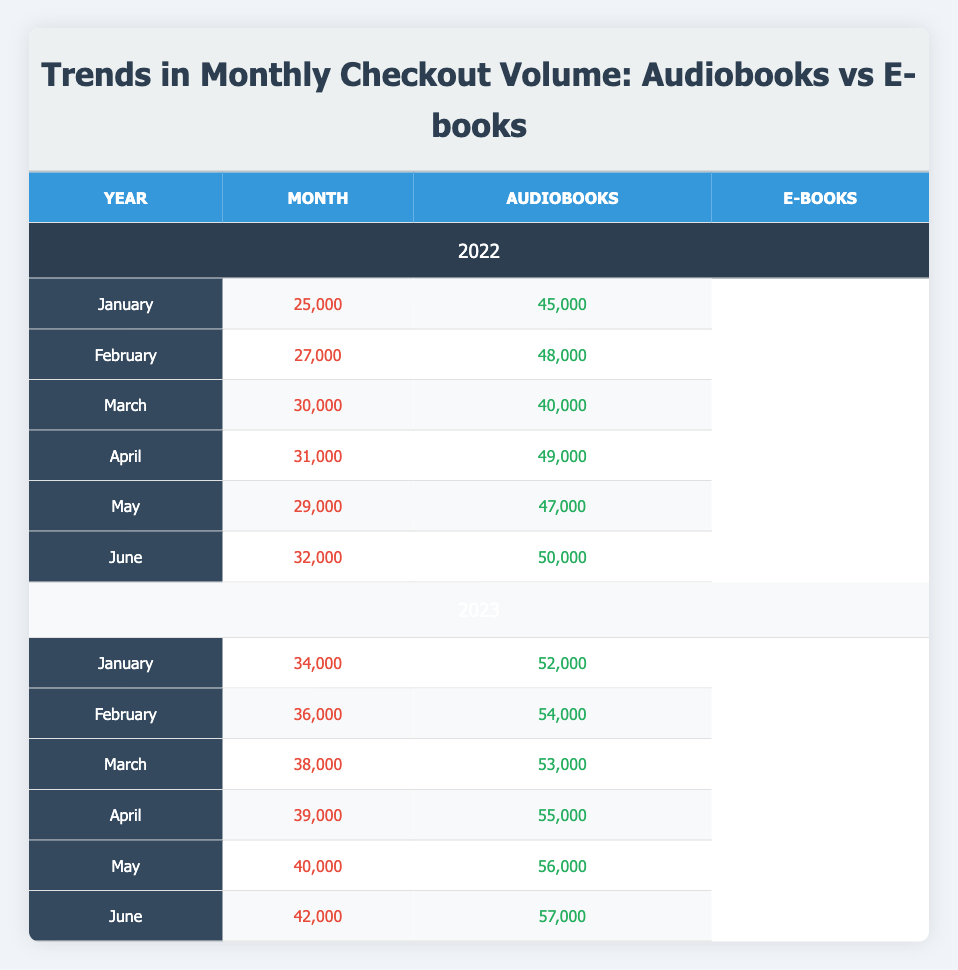What was the total volume of Audiobooks checked out in June 2022? In June 2022, the volume of Audiobooks checked out was 32,000.
Answer: 32,000 What was the average number of E-books checked out in the first half of 2023? The E-books checkouts for January to June 2023 are: 52,000, 54,000, 53,000, 55,000, 56,000, and 57,000. Summing them gives 327,000. Dividing by the 6 months results in an average of 54,500.
Answer: 54,500 Did Audiobooks see an increase in checkouts from January 2022 to June 2022? In January 2022, checkouts were 25,000 and in June 2022 they increased to 32,000, indicating an increase.
Answer: Yes What is the difference in checkout volume between Audiobooks and E-books in March 2023? In March 2023, Audiobooks had 38,000 checkouts and E-books had 53,000. The difference is 53,000 - 38,000 = 15,000.
Answer: 15,000 In which month of 2022 did Audiobooks have their highest checkout volume? By reviewing the data for 2022, the highest number of Audiobooks checked out was in June at 32,000.
Answer: June What was the total checkout volume for E-books from January to April 2023? The volumes are: January (52,000), February (54,000), March (53,000), and April (55,000). Adding these gives 214,000.
Answer: 214,000 Did E-books ever surpass Audiobooks in checkouts during 2022? Reviewing the data for 2022, E-books exceeded Audiobooks in every month, confirming they consistently had higher checkouts.
Answer: Yes What is the trend in Audiobooks checkout from January 2022 to June 2023? The data shows a steady increase in checkouts from January 2022 (25,000) to June 2023 (42,000), indicating a positive trend over time.
Answer: Positive trend 